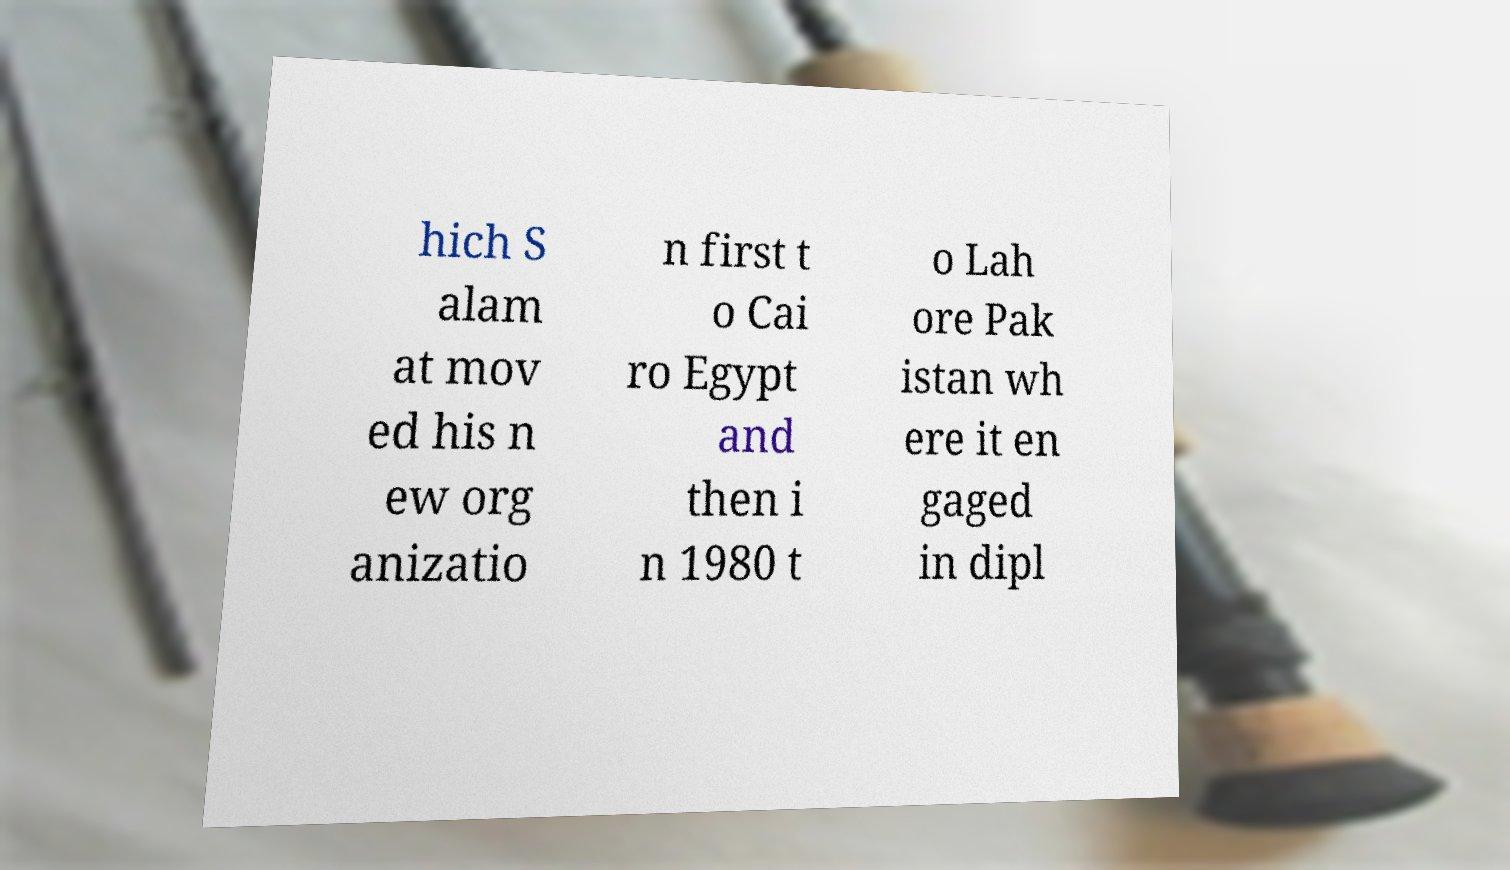There's text embedded in this image that I need extracted. Can you transcribe it verbatim? hich S alam at mov ed his n ew org anizatio n first t o Cai ro Egypt and then i n 1980 t o Lah ore Pak istan wh ere it en gaged in dipl 